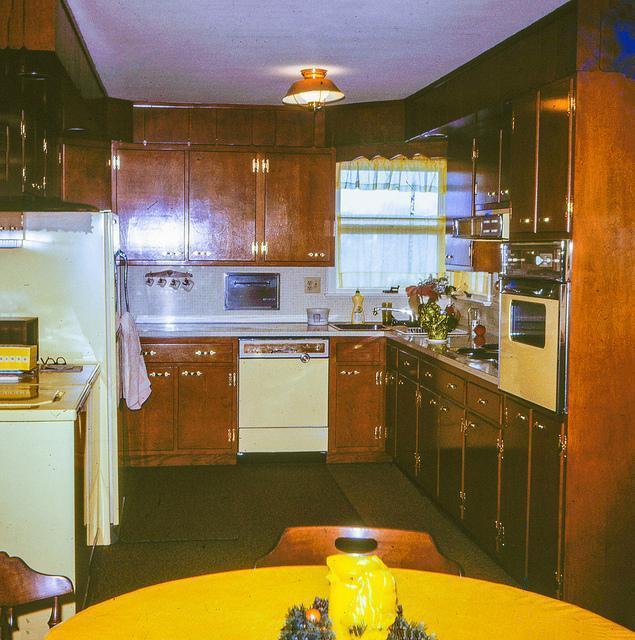How many chairs can be seen?
Give a very brief answer. 2. How many people are holding bats?
Give a very brief answer. 0. 